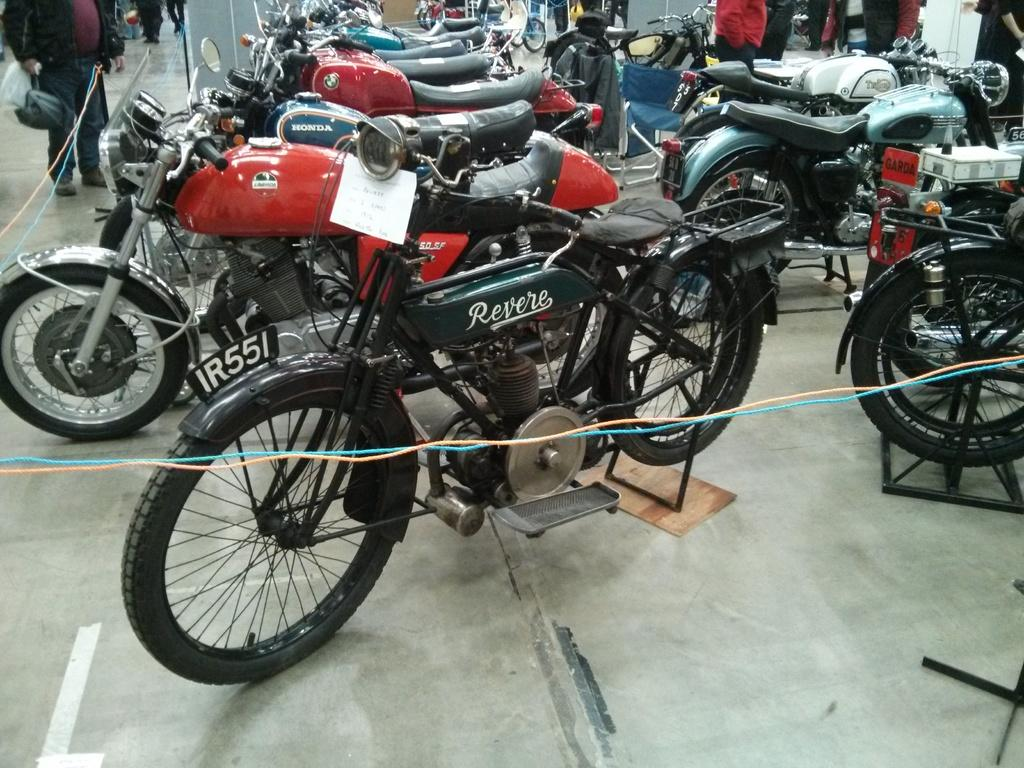What is the main subject of the image? The main subject of the image is many bikes. Can you describe the bike in the front? The bike in the front is green in color. What type of surface is visible in the image? There is a floor visible in the image. What is the person on the left side of the image doing? The person on the left side of the image is holding a bag and standing. What type of reaction can be seen from the rat in the image? There is no rat present in the image, so it is not possible to determine any reaction. 